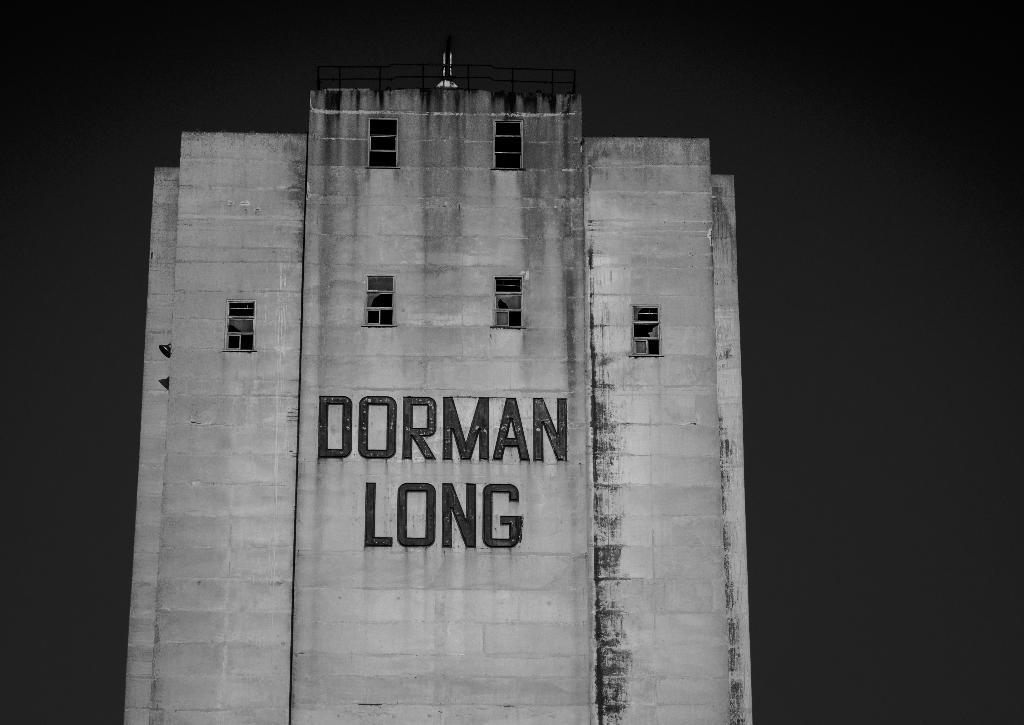What is the main structure in the image? There is a big building in the image. What is written on the building? The building has "Dorman Long" written on it. What can be observed about the background of the image? The background of the image is dark. Where is the van parked in the image? There is no van present in the image. How many people are in the crowd in the image? There is no crowd present in the image. What type of soup is being served in the image? There is no soup present in the image. 